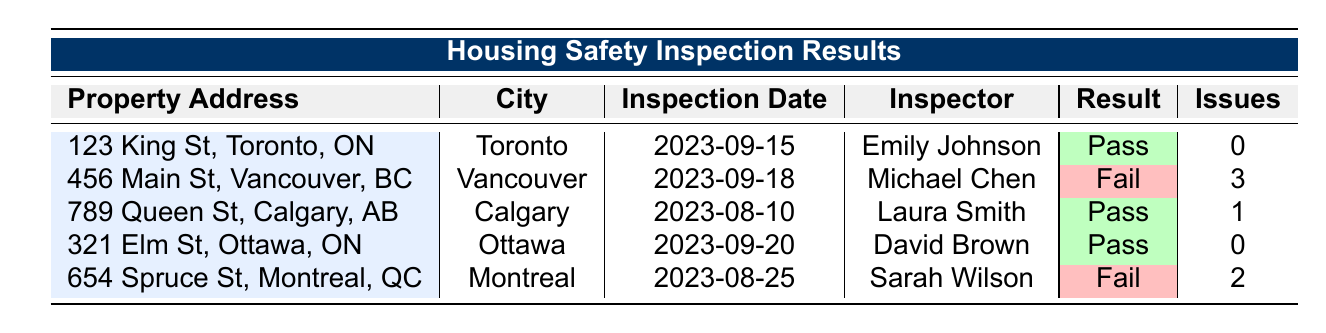What is the inspection date of the property at 123 King St, Toronto? The inspection date is listed in the corresponding row for the property at 123 King St, Toronto. Referring to that row, we see that the inspection date is 2023-09-15.
Answer: 2023-09-15 How many total issues were found across all properties? To find the total number of issues, we sum the issues found for each property: 0 (Toronto) + 3 (Vancouver) + 1 (Calgary) + 0 (Ottawa) + 2 (Montreal) = 6.
Answer: 6 Did the property at 456 Main St, Vancouver pass the inspection? We look at the result column for the property at 456 Main St, Vancouver, which shows "Fail." This means that the property did not pass the inspection.
Answer: No What is the average number of issues found in the properties? To calculate the average number of issues, we sum the issues (0 + 3 + 1 + 0 + 2) = 6, and divide by the total number of properties (5). Thus, the average is 6/5 = 1.2.
Answer: 1.2 Which city had a property that passed the inspection and had issues found? We look for properties with the result "Pass" but also have issues found greater than 0. The only property that fits this description is at 789 Queen St, Calgary, which has 1 issue found while passing the inspection. Thus, Calgary is the city that meets this criterion.
Answer: Calgary How many properties passed the inspection? We can just count the rows where the result is "Pass." From the table, we see that there are 3 properties that passed the inspection (Toronto, Calgary, Ottawa).
Answer: 3 Is there a property with both a pass result and issues identified? We check the table to see if any property has "Pass" in the result column and a number greater than 0 in issues. There are no properties that fit this description; therefore, the answer is negative.
Answer: No What type of notes were found for the failing property at 654 Spruce St, Montreal? Referring to the row for 654 Spruce St, Montreal, the notes state that there were hazardous materials found in the basement and mold growth detected.
Answer: Hazardous materials found in the basement, mold growth detected 